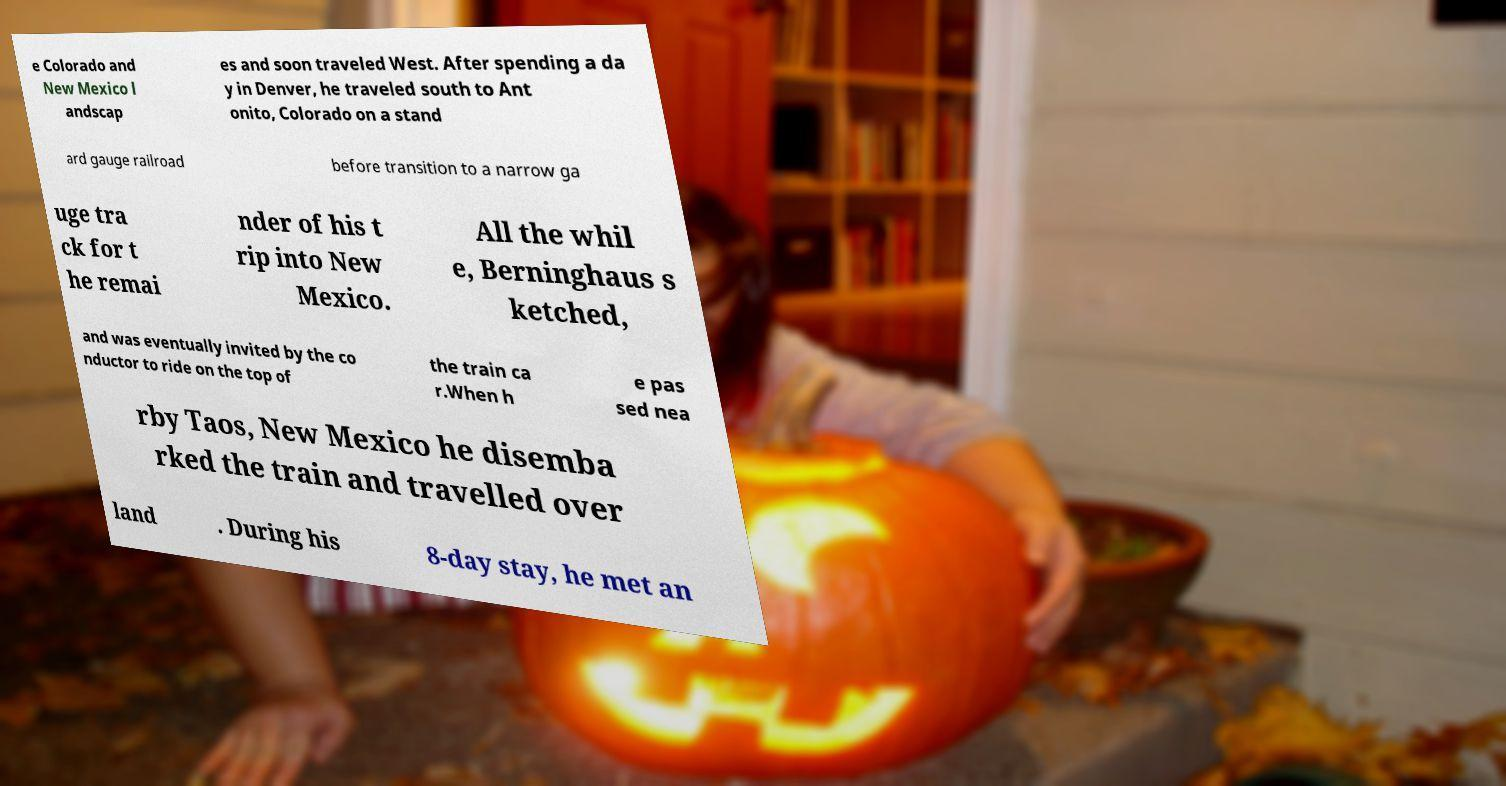There's text embedded in this image that I need extracted. Can you transcribe it verbatim? e Colorado and New Mexico l andscap es and soon traveled West. After spending a da y in Denver, he traveled south to Ant onito, Colorado on a stand ard gauge railroad before transition to a narrow ga uge tra ck for t he remai nder of his t rip into New Mexico. All the whil e, Berninghaus s ketched, and was eventually invited by the co nductor to ride on the top of the train ca r.When h e pas sed nea rby Taos, New Mexico he disemba rked the train and travelled over land . During his 8-day stay, he met an 